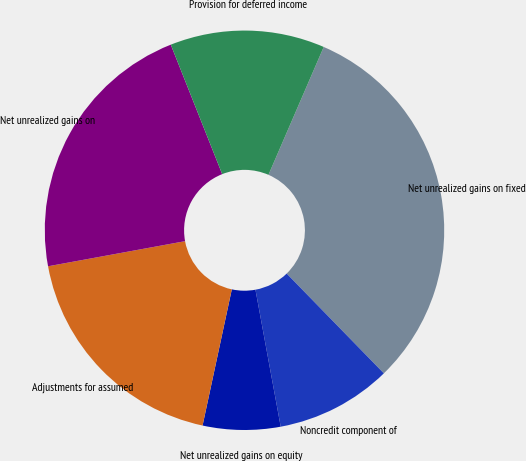Convert chart to OTSL. <chart><loc_0><loc_0><loc_500><loc_500><pie_chart><fcel>Net unrealized gains on fixed<fcel>Noncredit component of<fcel>Net unrealized gains on equity<fcel>Adjustments for assumed<fcel>Net unrealized gains on<fcel>Provision for deferred income<nl><fcel>31.22%<fcel>9.39%<fcel>6.27%<fcel>18.75%<fcel>21.87%<fcel>12.51%<nl></chart> 